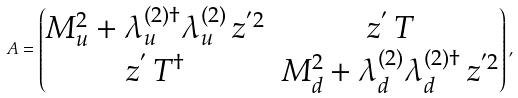<formula> <loc_0><loc_0><loc_500><loc_500>A = \begin{pmatrix} M _ { u } ^ { 2 } + \lambda _ { u } ^ { ( 2 ) \dagger } \lambda _ { u } ^ { ( 2 ) } \, z ^ { ^ { \prime } 2 } & z ^ { ^ { \prime } } \, T \\ z ^ { ^ { \prime } } \, T ^ { \dagger } & M _ { d } ^ { 2 } + \lambda _ { d } ^ { ( 2 ) } \lambda _ { d } ^ { ( 2 ) \dagger } \, z ^ { ^ { \prime } 2 } \end{pmatrix} ,</formula> 